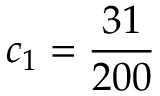<formula> <loc_0><loc_0><loc_500><loc_500>c _ { 1 } = { \frac { 3 1 } { 2 0 0 } }</formula> 